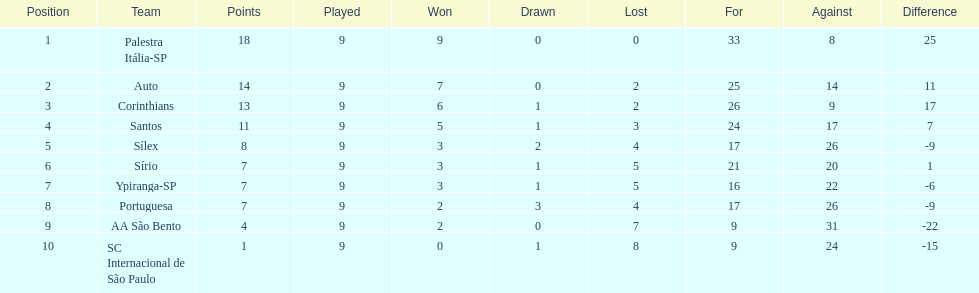Which team was the top scoring team? Palestra Itália-SP. 